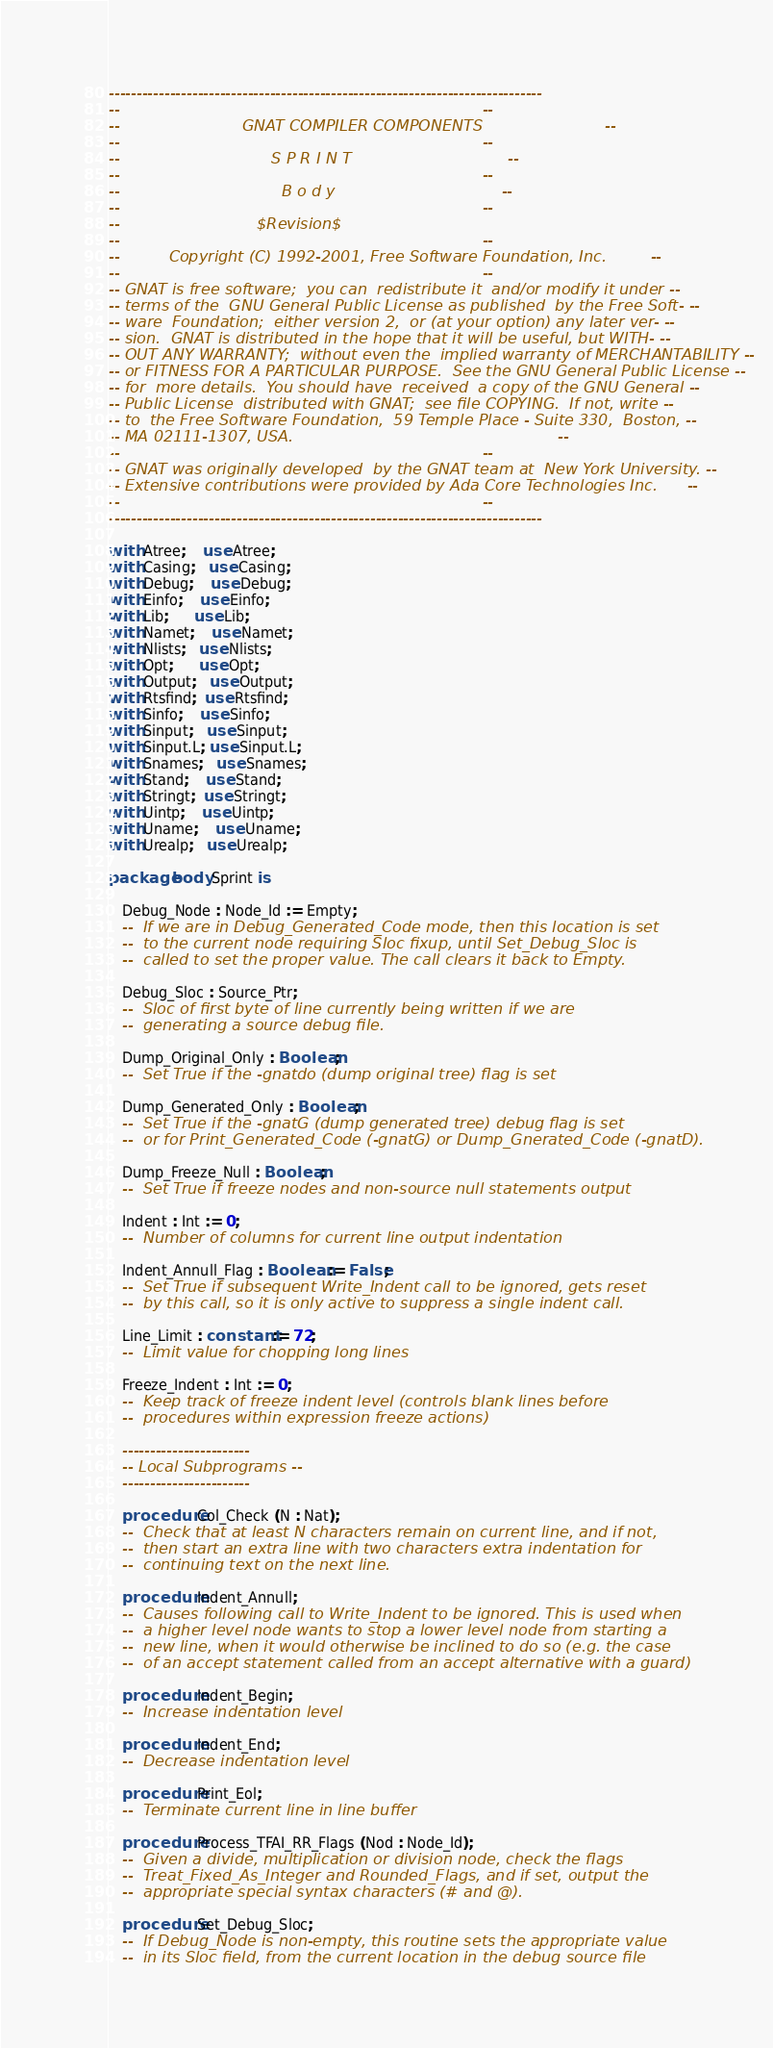Convert code to text. <code><loc_0><loc_0><loc_500><loc_500><_Ada_>------------------------------------------------------------------------------
--                                                                          --
--                         GNAT COMPILER COMPONENTS                         --
--                                                                          --
--                               S P R I N T                                --
--                                                                          --
--                                 B o d y                                  --
--                                                                          --
--                            $Revision$
--                                                                          --
--          Copyright (C) 1992-2001, Free Software Foundation, Inc.         --
--                                                                          --
-- GNAT is free software;  you can  redistribute it  and/or modify it under --
-- terms of the  GNU General Public License as published  by the Free Soft- --
-- ware  Foundation;  either version 2,  or (at your option) any later ver- --
-- sion.  GNAT is distributed in the hope that it will be useful, but WITH- --
-- OUT ANY WARRANTY;  without even the  implied warranty of MERCHANTABILITY --
-- or FITNESS FOR A PARTICULAR PURPOSE.  See the GNU General Public License --
-- for  more details.  You should have  received  a copy of the GNU General --
-- Public License  distributed with GNAT;  see file COPYING.  If not, write --
-- to  the Free Software Foundation,  59 Temple Place - Suite 330,  Boston, --
-- MA 02111-1307, USA.                                                      --
--                                                                          --
-- GNAT was originally developed  by the GNAT team at  New York University. --
-- Extensive contributions were provided by Ada Core Technologies Inc.      --
--                                                                          --
------------------------------------------------------------------------------

with Atree;    use Atree;
with Casing;   use Casing;
with Debug;    use Debug;
with Einfo;    use Einfo;
with Lib;      use Lib;
with Namet;    use Namet;
with Nlists;   use Nlists;
with Opt;      use Opt;
with Output;   use Output;
with Rtsfind;  use Rtsfind;
with Sinfo;    use Sinfo;
with Sinput;   use Sinput;
with Sinput.L; use Sinput.L;
with Snames;   use Snames;
with Stand;    use Stand;
with Stringt;  use Stringt;
with Uintp;    use Uintp;
with Uname;    use Uname;
with Urealp;   use Urealp;

package body Sprint is

   Debug_Node : Node_Id := Empty;
   --  If we are in Debug_Generated_Code mode, then this location is set
   --  to the current node requiring Sloc fixup, until Set_Debug_Sloc is
   --  called to set the proper value. The call clears it back to Empty.

   Debug_Sloc : Source_Ptr;
   --  Sloc of first byte of line currently being written if we are
   --  generating a source debug file.

   Dump_Original_Only : Boolean;
   --  Set True if the -gnatdo (dump original tree) flag is set

   Dump_Generated_Only : Boolean;
   --  Set True if the -gnatG (dump generated tree) debug flag is set
   --  or for Print_Generated_Code (-gnatG) or Dump_Gnerated_Code (-gnatD).

   Dump_Freeze_Null : Boolean;
   --  Set True if freeze nodes and non-source null statements output

   Indent : Int := 0;
   --  Number of columns for current line output indentation

   Indent_Annull_Flag : Boolean := False;
   --  Set True if subsequent Write_Indent call to be ignored, gets reset
   --  by this call, so it is only active to suppress a single indent call.

   Line_Limit : constant := 72;
   --  Limit value for chopping long lines

   Freeze_Indent : Int := 0;
   --  Keep track of freeze indent level (controls blank lines before
   --  procedures within expression freeze actions)

   -----------------------
   -- Local Subprograms --
   -----------------------

   procedure Col_Check (N : Nat);
   --  Check that at least N characters remain on current line, and if not,
   --  then start an extra line with two characters extra indentation for
   --  continuing text on the next line.

   procedure Indent_Annull;
   --  Causes following call to Write_Indent to be ignored. This is used when
   --  a higher level node wants to stop a lower level node from starting a
   --  new line, when it would otherwise be inclined to do so (e.g. the case
   --  of an accept statement called from an accept alternative with a guard)

   procedure Indent_Begin;
   --  Increase indentation level

   procedure Indent_End;
   --  Decrease indentation level

   procedure Print_Eol;
   --  Terminate current line in line buffer

   procedure Process_TFAI_RR_Flags (Nod : Node_Id);
   --  Given a divide, multiplication or division node, check the flags
   --  Treat_Fixed_As_Integer and Rounded_Flags, and if set, output the
   --  appropriate special syntax characters (# and @).

   procedure Set_Debug_Sloc;
   --  If Debug_Node is non-empty, this routine sets the appropriate value
   --  in its Sloc field, from the current location in the debug source file</code> 